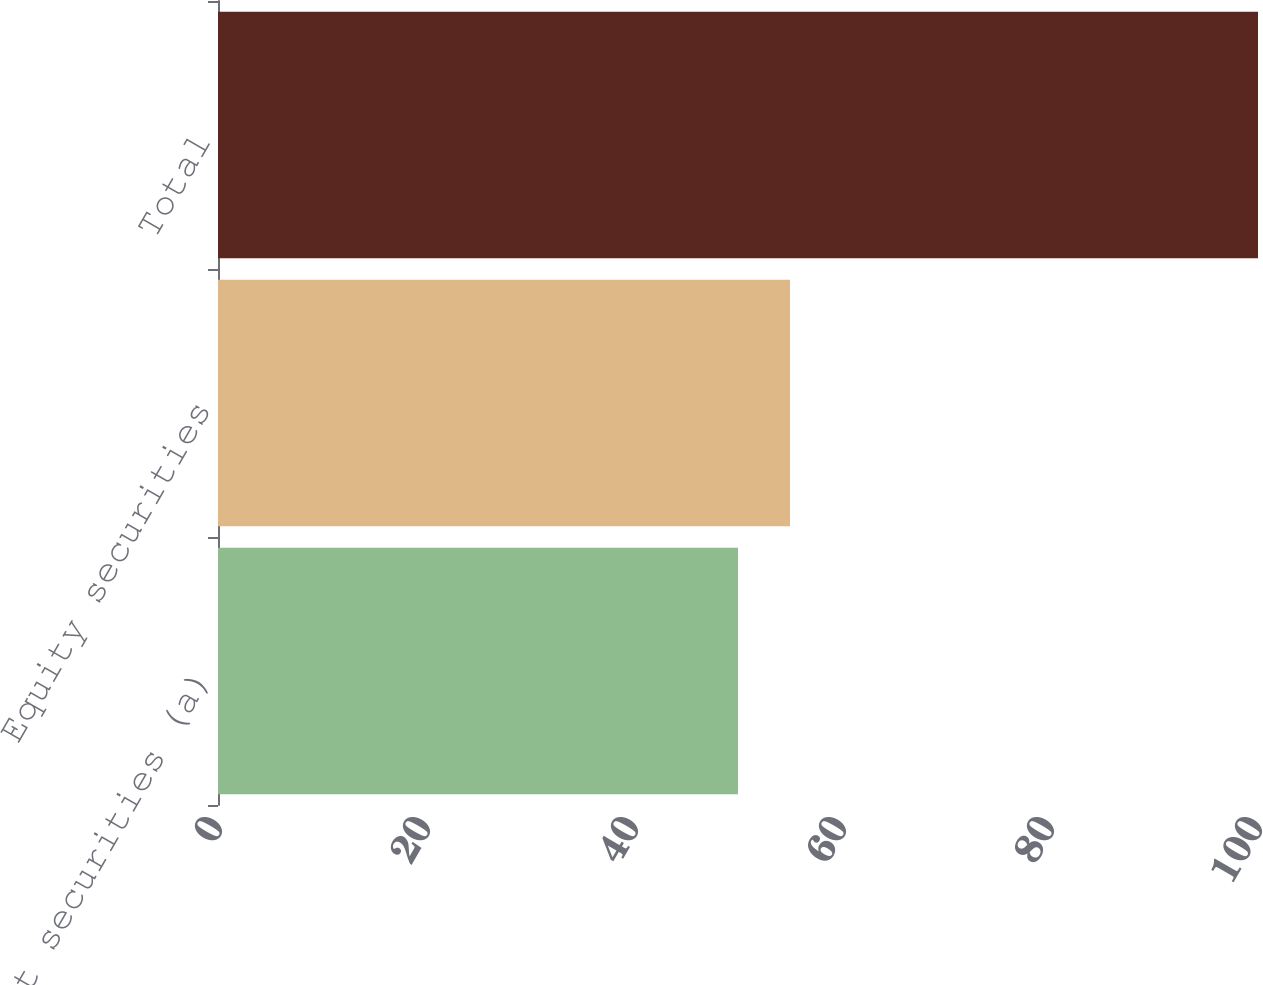<chart> <loc_0><loc_0><loc_500><loc_500><bar_chart><fcel>Debt securities (a)<fcel>Equity securities<fcel>Total<nl><fcel>50<fcel>55<fcel>100<nl></chart> 